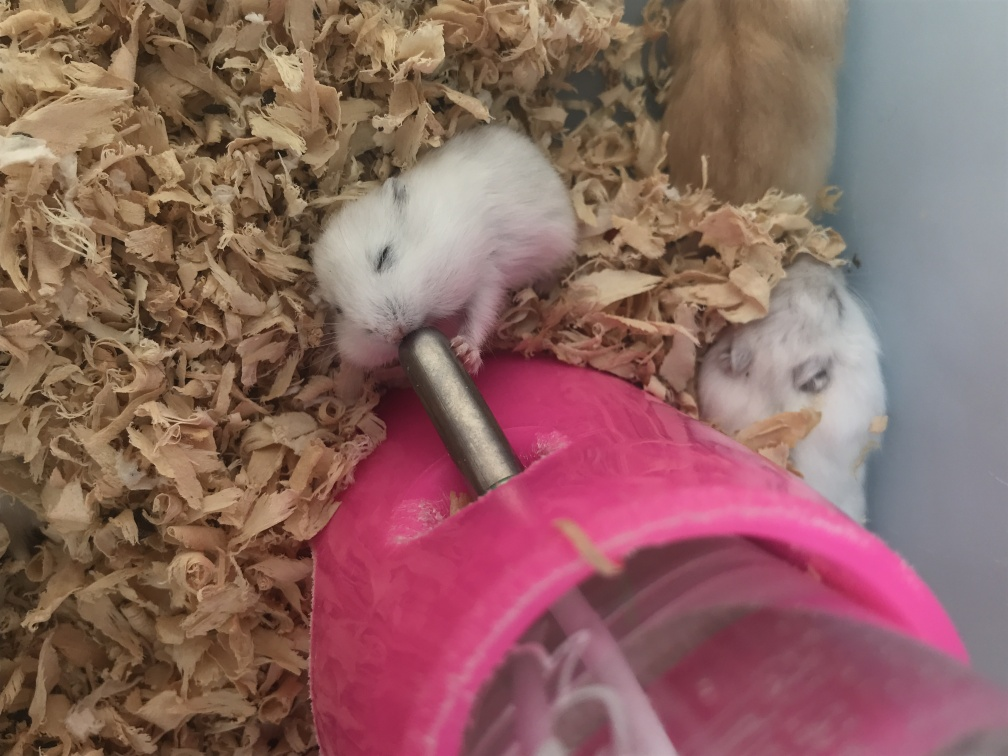What can you infer about their habitat from this image? The image shows the hamsters in an enclosure with a substrate of wood shavings, suggesting it's designed to mimic a burrowing environment, which is common for hamsters. The presence of the water bottle indicates that these are pet hamsters in a human-created habitat. Do they look healthy and well-cared for? From what is visible, the hamsters appear to be healthy; they are active and their fur looks clean. However, a thorough assessment would require more information about their diet, overall living conditions, and behavior beyond this single snapshot. 